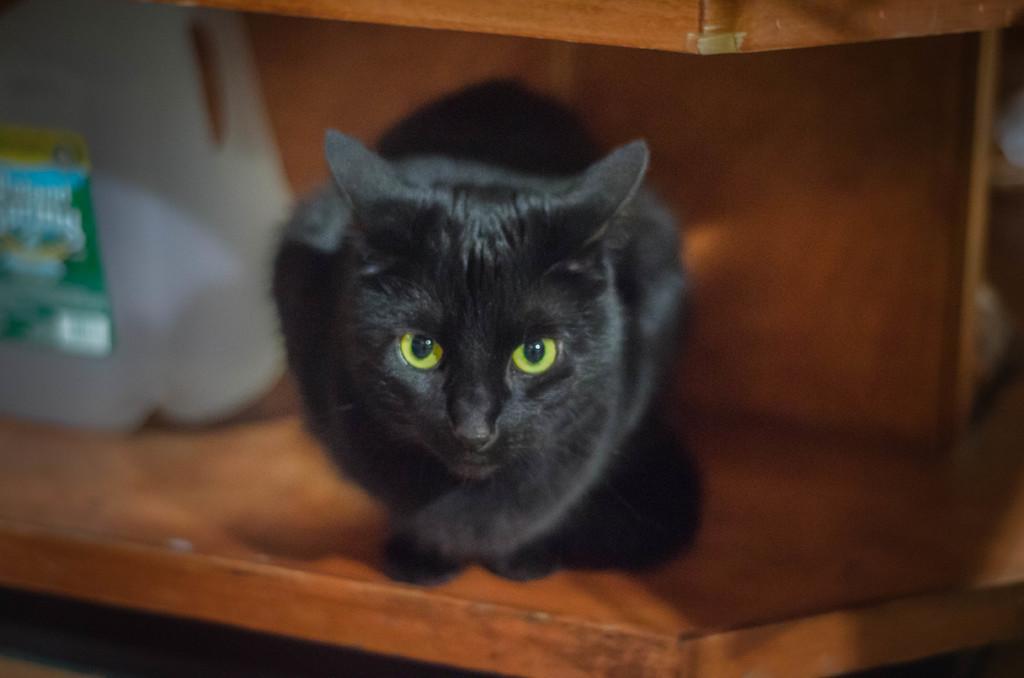Please provide a concise description of this image. In this picture I can see a black color cat in front and it is on the brown color surface and I can see a white color thing on the left side of this image and I see that it is blurred. 